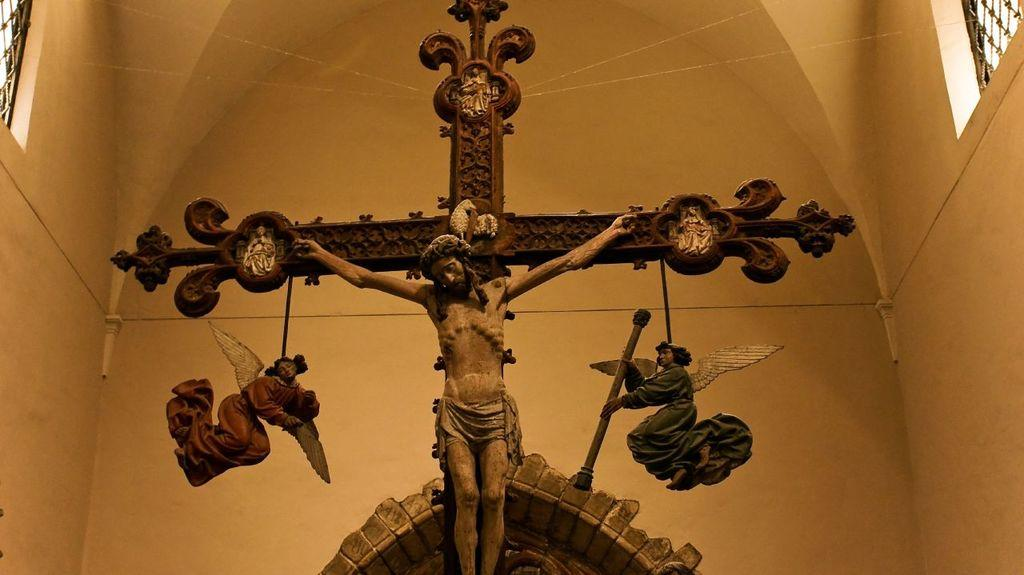What is depicted on the cross in the image? There are statues on a cross in the image. What type of structure can be seen in the background of the image? There is a wall visible in the image. What architectural feature is present on the wall? There are windows on the wall in the image. How many snails can be seen crawling on the wall in the image? There are no snails present in the image; it features statues on a cross and a wall with windows. What message of hope is conveyed by the statues on the cross in the image? The image does not convey a specific message of hope; it simply depicts statues on a cross and a wall with windows. 